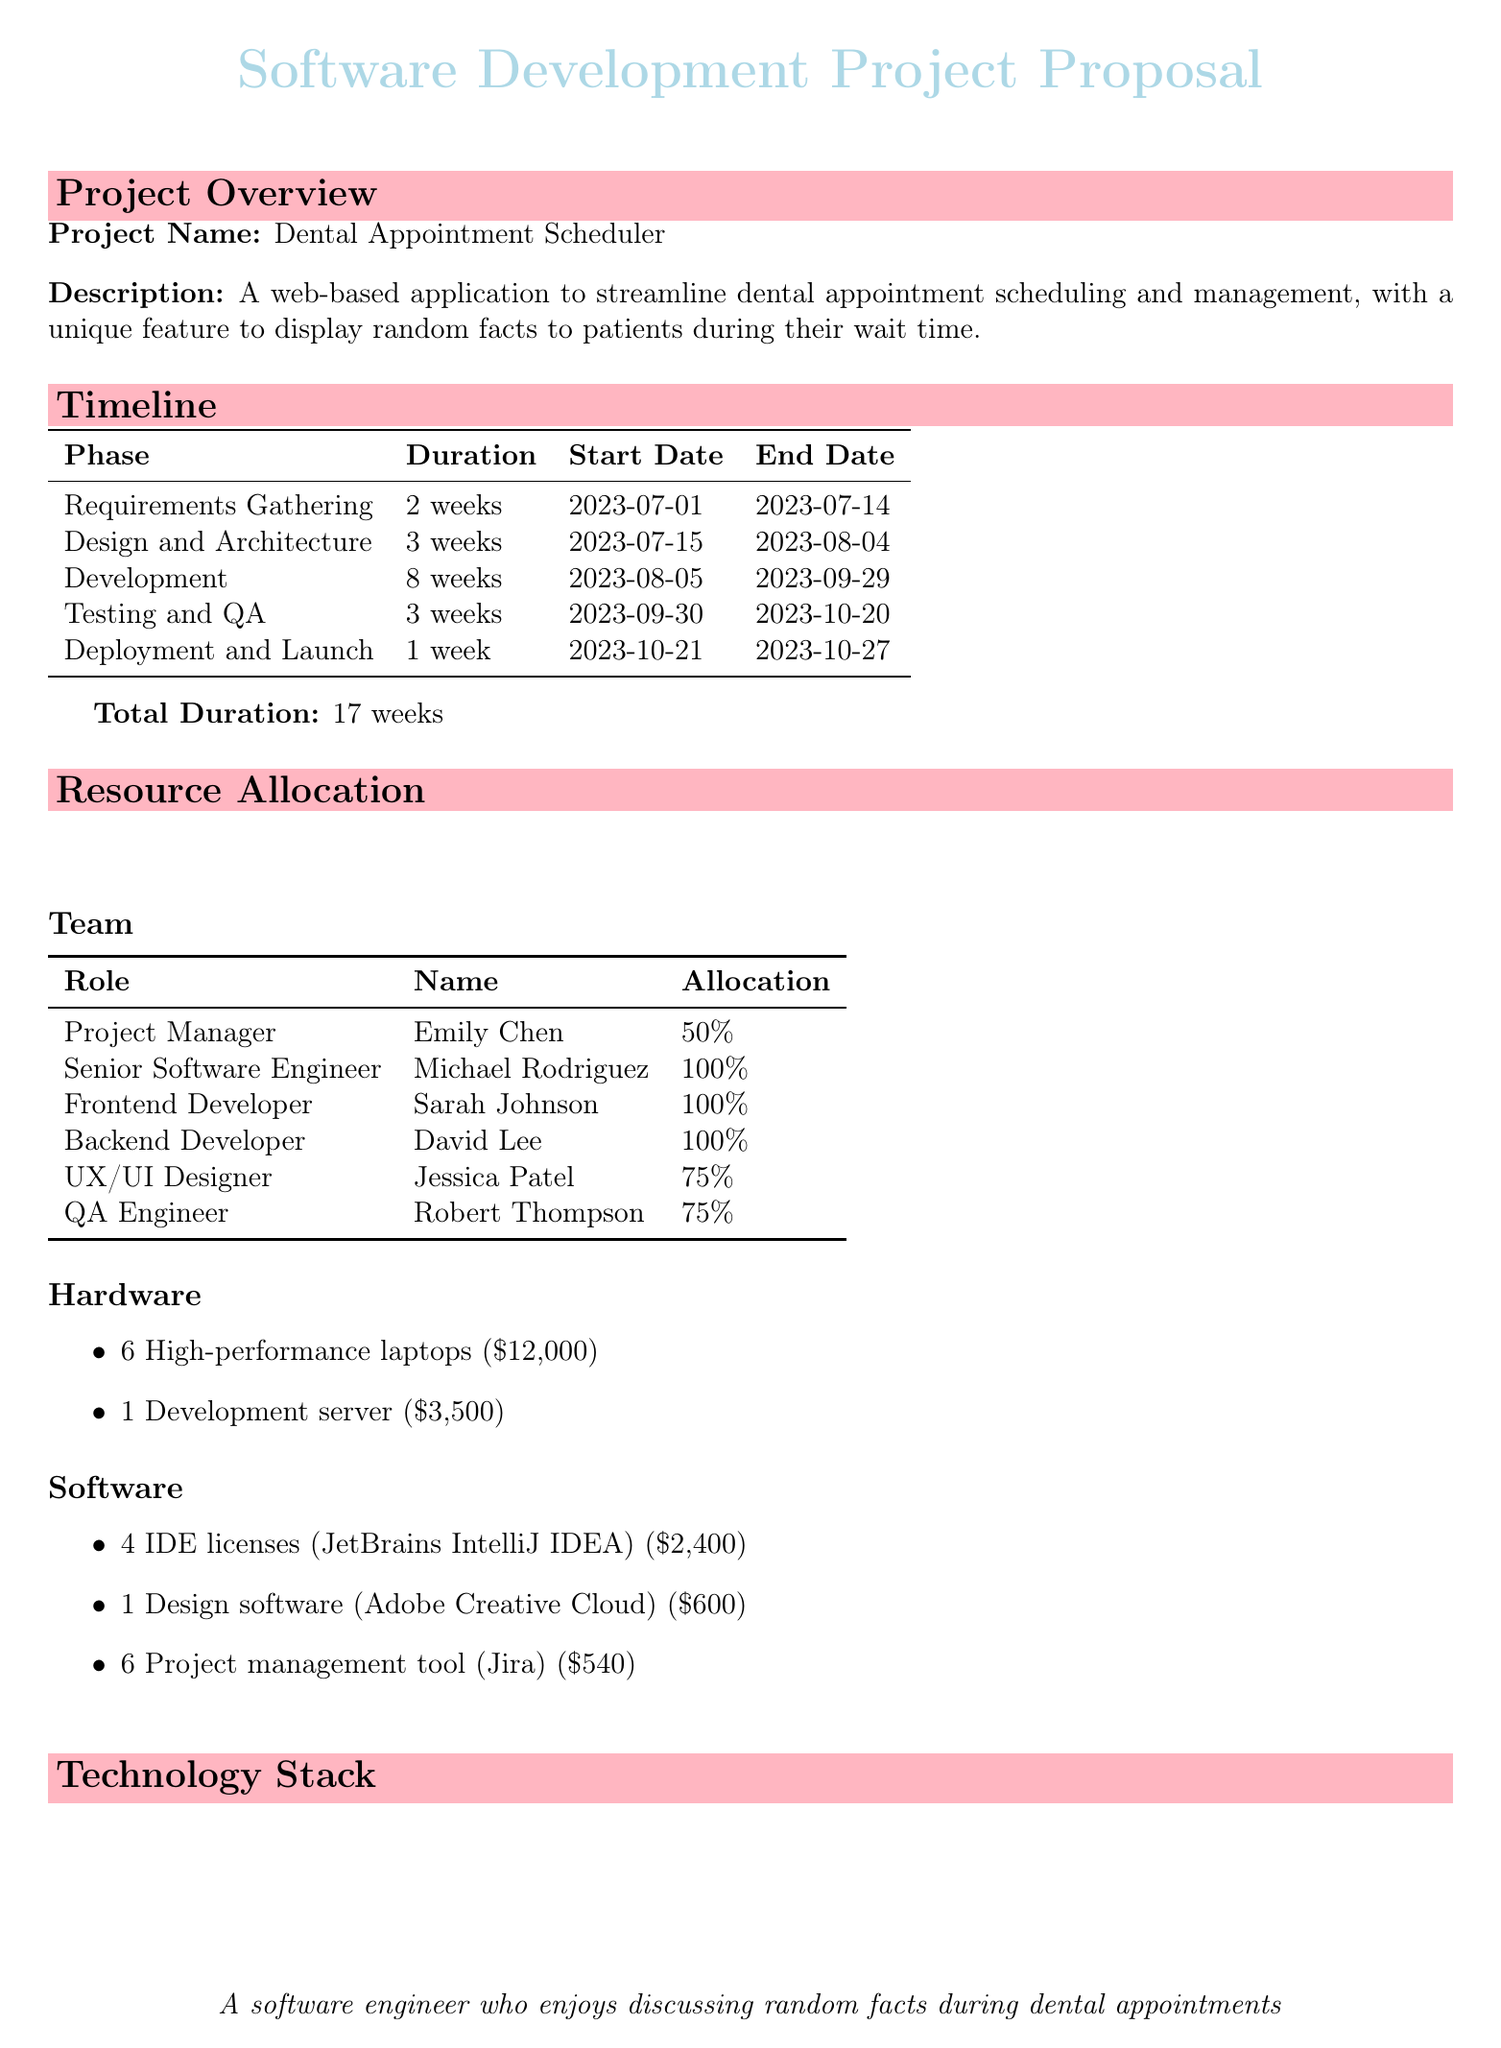What is the project name? The project name is clearly stated in the overview section of the document.
Answer: Dental Appointment Scheduler How long is the development phase? The development phase duration can be found in the timeline section, along with dates.
Answer: 8 weeks Who is the Project Manager? The document lists the names of the team members along with their roles in the resource allocation section.
Answer: Emily Chen What technology is used for back-end database management? The technology stack section specifies which database management system is being used.
Answer: PostgreSQL What is the total cost of hardware items? The total cost is derived from adding the costs of all listed hardware items in the resource allocation section.
Answer: $15,500 Which tool is used for continuous integration and deployment? This is specified in the DevOps section of the technology stack, which lists the tools included.
Answer: Jenkins What is the total duration of the project? The total duration summarizes the entire timeline, indicating how long the project will take to complete.
Answer: 17 weeks How many IDE licenses are needed? The software section specifies the quantity required for a particular software tool for the project.
Answer: 4 What is the unique feature of the application? The unique feature is mentioned in the project description section, summarizing the primary function of the application.
Answer: Random Fact Generator 